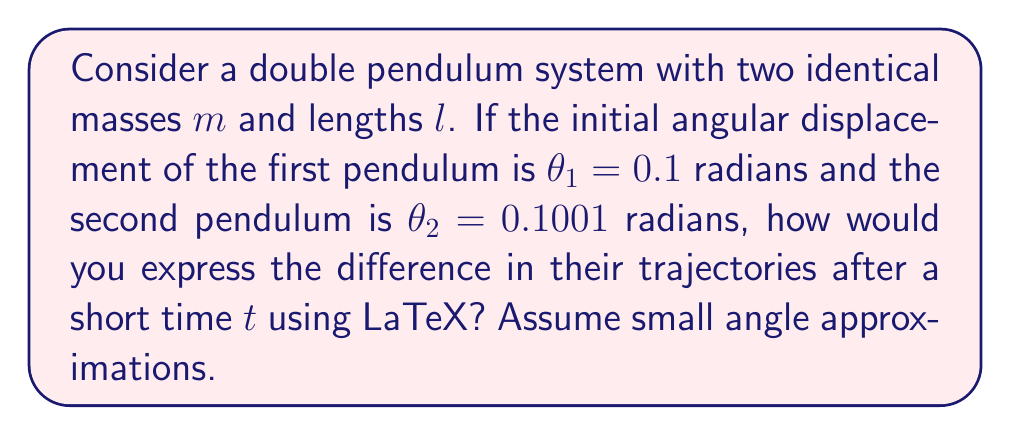Can you answer this question? To analyze the sensitivity to initial conditions in the double pendulum system, we'll follow these steps:

1. For small angles, the equations of motion for a double pendulum can be approximated as:

   $$\ddot{\theta_1} \approx -\frac{3g}{2l}\theta_1 + \frac{g}{2l}\theta_2$$
   $$\ddot{\theta_2} \approx 2\frac{g}{l}\theta_1 - 2\frac{g}{l}\theta_2$$

2. For small time intervals, we can approximate the solution using Taylor series:

   $$\theta_1(t) \approx \theta_1(0) + \dot{\theta_1}(0)t + \frac{1}{2}\ddot{\theta_1}(0)t^2$$
   $$\theta_2(t) \approx \theta_2(0) + \dot{\theta_2}(0)t + \frac{1}{2}\ddot{\theta_2}(0)t^2$$

3. Initially, we assume $\dot{\theta_1}(0) = \dot{\theta_2}(0) = 0$. Substituting the initial conditions:

   $$\theta_1(t) \approx 0.1 + \frac{1}{2}\ddot{\theta_1}(0)t^2$$
   $$\theta_2(t) \approx 0.1001 + \frac{1}{2}\ddot{\theta_2}(0)t^2$$

4. Calculate $\ddot{\theta_1}(0)$ and $\ddot{\theta_2}(0)$ using the equations of motion:

   $$\ddot{\theta_1}(0) \approx -\frac{3g}{2l}(0.1) + \frac{g}{2l}(0.1001) = -0.14995\frac{g}{l}$$
   $$\ddot{\theta_2}(0) \approx 2\frac{g}{l}(0.1) - 2\frac{g}{l}(0.1001) = -0.0002\frac{g}{l}$$

5. Substitute these values back into the Taylor series approximations:

   $$\theta_1(t) \approx 0.1 - 0.074975\frac{g}{l}t^2$$
   $$\theta_2(t) \approx 0.1001 - 0.0001\frac{g}{l}t^2$$

6. The difference in trajectories can be expressed as:

   $$\Delta\theta(t) = \theta_2(t) - \theta_1(t) \approx 0.0001 + 0.074875\frac{g}{l}t^2$$

This expression shows how the initially small difference (0.0001 radians) grows quadratically with time, demonstrating the system's sensitivity to initial conditions.
Answer: $\Delta\theta(t) \approx 0.0001 + 0.074875\frac{g}{l}t^2$ 